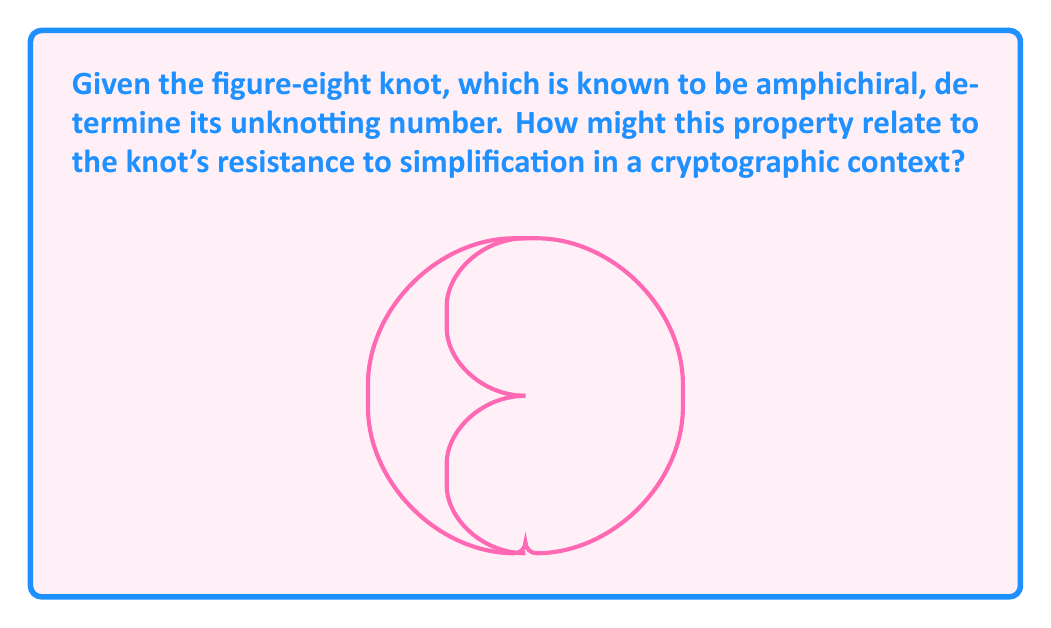Show me your answer to this math problem. To determine the unknotting number of the figure-eight knot, we need to follow these steps:

1) The unknotting number of a knot is the minimum number of crossing changes required to transform the knot into the unknot (trivial knot).

2) For the figure-eight knot:
   a) It has a crossing number of 4, which means it has 4 crossings in its minimal diagram.
   b) It is known to be alternating, which means the crossings alternate between over and under as we travel along the knot.
   c) It is also known to be amphichiral, meaning it is equivalent to its mirror image.

3) For alternating knots, the unknotting number is always less than or equal to half the crossing number. So, we know that:

   $$ \text{unknotting number} \leq \frac{\text{crossing number}}{2} = \frac{4}{2} = 2 $$

4) However, the figure-eight knot cannot be unknotted with just one crossing change. This can be proven using various knot invariants, such as the Jones polynomial or the signature.

5) Therefore, the unknotting number of the figure-eight knot must be exactly 2.

In a cryptographic context, the unknotting number can be related to the knot's resistance to simplification:

6) A higher unknotting number generally indicates a more complex knot structure, which could potentially offer more resistance to cryptographic attacks based on knot simplification.

7) The fact that the figure-eight knot is amphichiral adds another layer of complexity, as it means the knot remains equivalent under reflection. This property could potentially make certain types of cryptographic analysis more challenging.

8) However, with an unknotting number of 2, the figure-eight knot is still relatively simple compared to more complex knots. In a cryptographic system, knots with higher unknotting numbers might be preferred for increased security.
Answer: 2 